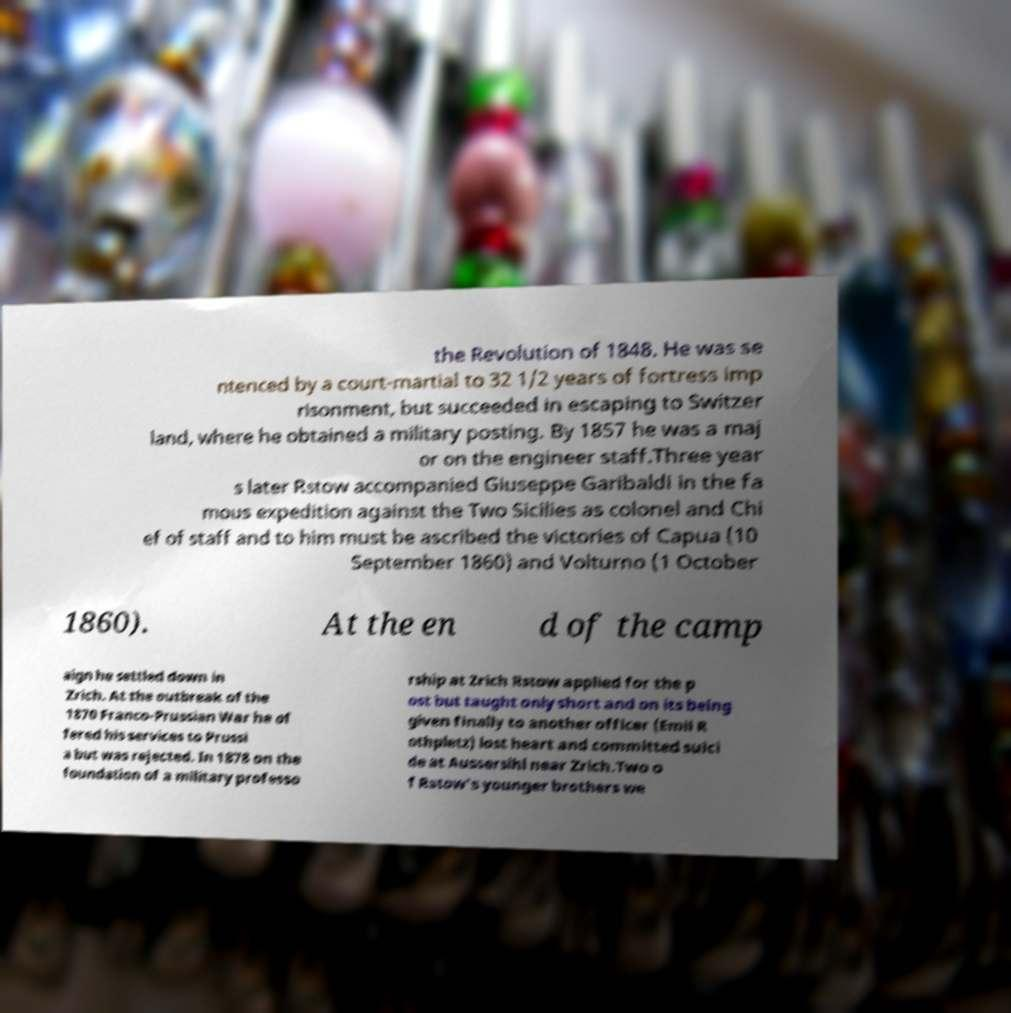I need the written content from this picture converted into text. Can you do that? the Revolution of 1848. He was se ntenced by a court-martial to 32 1/2 years of fortress imp risonment, but succeeded in escaping to Switzer land, where he obtained a military posting. By 1857 he was a maj or on the engineer staff.Three year s later Rstow accompanied Giuseppe Garibaldi in the fa mous expedition against the Two Sicilies as colonel and Chi ef of staff and to him must be ascribed the victories of Capua (10 September 1860) and Volturno (1 October 1860). At the en d of the camp aign he settled down in Zrich. At the outbreak of the 1870 Franco-Prussian War he of fered his services to Prussi a but was rejected. In 1878 on the foundation of a military professo rship at Zrich Rstow applied for the p ost but taught only short and on its being given finally to another officer (Emil R othpletz) lost heart and committed suici de at Aussersihl near Zrich.Two o f Rstow's younger brothers we 